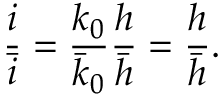Convert formula to latex. <formula><loc_0><loc_0><loc_500><loc_500>\frac { i } { \bar { i } } = \frac { k _ { 0 } } { \bar { k } _ { 0 } } \frac { h } { \bar { h } } = \frac { h } { \bar { h } } .</formula> 